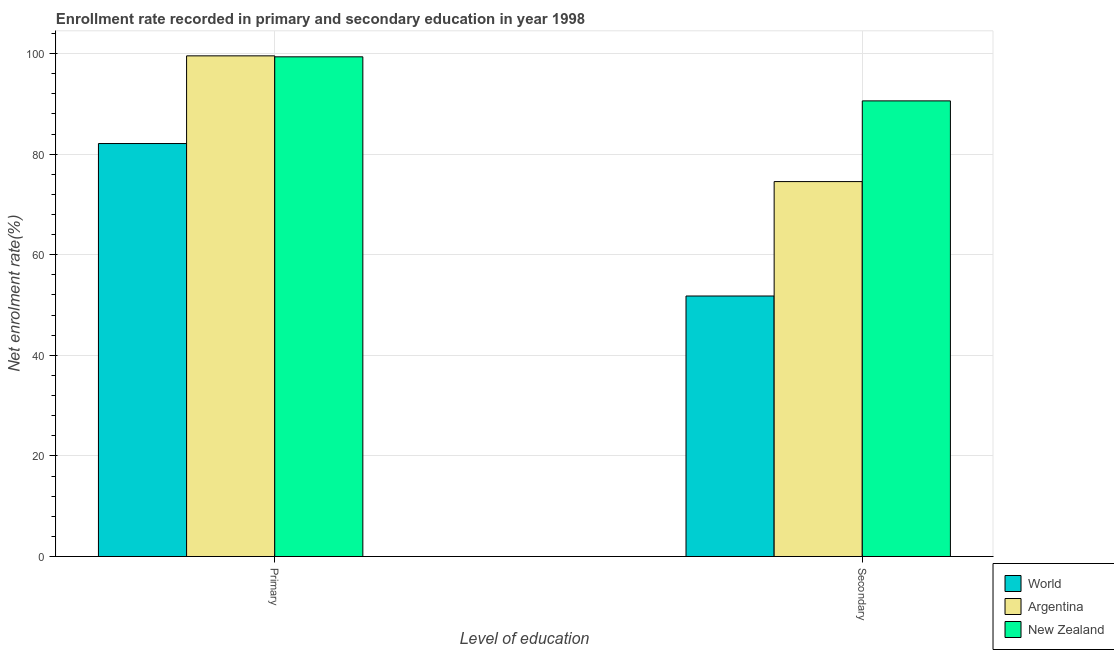How many groups of bars are there?
Make the answer very short. 2. How many bars are there on the 2nd tick from the left?
Your answer should be compact. 3. What is the label of the 1st group of bars from the left?
Offer a very short reply. Primary. What is the enrollment rate in secondary education in Argentina?
Your response must be concise. 74.55. Across all countries, what is the maximum enrollment rate in secondary education?
Keep it short and to the point. 90.59. Across all countries, what is the minimum enrollment rate in secondary education?
Keep it short and to the point. 51.8. In which country was the enrollment rate in primary education maximum?
Your answer should be very brief. Argentina. What is the total enrollment rate in primary education in the graph?
Keep it short and to the point. 281.01. What is the difference between the enrollment rate in secondary education in Argentina and that in New Zealand?
Provide a short and direct response. -16.04. What is the difference between the enrollment rate in primary education in World and the enrollment rate in secondary education in New Zealand?
Provide a short and direct response. -8.48. What is the average enrollment rate in primary education per country?
Your answer should be compact. 93.67. What is the difference between the enrollment rate in secondary education and enrollment rate in primary education in Argentina?
Give a very brief answer. -25. In how many countries, is the enrollment rate in primary education greater than 24 %?
Make the answer very short. 3. What is the ratio of the enrollment rate in primary education in World to that in Argentina?
Your answer should be compact. 0.82. Is the enrollment rate in secondary education in New Zealand less than that in Argentina?
Your answer should be very brief. No. What does the 3rd bar from the right in Secondary represents?
Make the answer very short. World. Are all the bars in the graph horizontal?
Provide a short and direct response. No. What is the difference between two consecutive major ticks on the Y-axis?
Provide a succinct answer. 20. Are the values on the major ticks of Y-axis written in scientific E-notation?
Ensure brevity in your answer.  No. Does the graph contain any zero values?
Provide a succinct answer. No. Where does the legend appear in the graph?
Give a very brief answer. Bottom right. How many legend labels are there?
Give a very brief answer. 3. What is the title of the graph?
Your answer should be very brief. Enrollment rate recorded in primary and secondary education in year 1998. Does "Europe(all income levels)" appear as one of the legend labels in the graph?
Give a very brief answer. No. What is the label or title of the X-axis?
Give a very brief answer. Level of education. What is the label or title of the Y-axis?
Offer a very short reply. Net enrolment rate(%). What is the Net enrolment rate(%) of World in Primary?
Your answer should be very brief. 82.11. What is the Net enrolment rate(%) in Argentina in Primary?
Keep it short and to the point. 99.55. What is the Net enrolment rate(%) in New Zealand in Primary?
Keep it short and to the point. 99.35. What is the Net enrolment rate(%) of World in Secondary?
Your answer should be compact. 51.8. What is the Net enrolment rate(%) in Argentina in Secondary?
Provide a succinct answer. 74.55. What is the Net enrolment rate(%) of New Zealand in Secondary?
Provide a short and direct response. 90.59. Across all Level of education, what is the maximum Net enrolment rate(%) in World?
Your answer should be very brief. 82.11. Across all Level of education, what is the maximum Net enrolment rate(%) in Argentina?
Your answer should be compact. 99.55. Across all Level of education, what is the maximum Net enrolment rate(%) in New Zealand?
Give a very brief answer. 99.35. Across all Level of education, what is the minimum Net enrolment rate(%) in World?
Your answer should be very brief. 51.8. Across all Level of education, what is the minimum Net enrolment rate(%) in Argentina?
Give a very brief answer. 74.55. Across all Level of education, what is the minimum Net enrolment rate(%) in New Zealand?
Provide a short and direct response. 90.59. What is the total Net enrolment rate(%) in World in the graph?
Offer a terse response. 133.91. What is the total Net enrolment rate(%) of Argentina in the graph?
Provide a succinct answer. 174.09. What is the total Net enrolment rate(%) in New Zealand in the graph?
Offer a very short reply. 189.94. What is the difference between the Net enrolment rate(%) of World in Primary and that in Secondary?
Ensure brevity in your answer.  30.32. What is the difference between the Net enrolment rate(%) in Argentina in Primary and that in Secondary?
Ensure brevity in your answer.  25. What is the difference between the Net enrolment rate(%) in New Zealand in Primary and that in Secondary?
Offer a terse response. 8.76. What is the difference between the Net enrolment rate(%) of World in Primary and the Net enrolment rate(%) of Argentina in Secondary?
Ensure brevity in your answer.  7.56. What is the difference between the Net enrolment rate(%) of World in Primary and the Net enrolment rate(%) of New Zealand in Secondary?
Offer a terse response. -8.48. What is the difference between the Net enrolment rate(%) of Argentina in Primary and the Net enrolment rate(%) of New Zealand in Secondary?
Your response must be concise. 8.95. What is the average Net enrolment rate(%) in World per Level of education?
Make the answer very short. 66.95. What is the average Net enrolment rate(%) in Argentina per Level of education?
Provide a short and direct response. 87.05. What is the average Net enrolment rate(%) in New Zealand per Level of education?
Offer a terse response. 94.97. What is the difference between the Net enrolment rate(%) in World and Net enrolment rate(%) in Argentina in Primary?
Offer a very short reply. -17.43. What is the difference between the Net enrolment rate(%) in World and Net enrolment rate(%) in New Zealand in Primary?
Your response must be concise. -17.24. What is the difference between the Net enrolment rate(%) of Argentina and Net enrolment rate(%) of New Zealand in Primary?
Provide a succinct answer. 0.19. What is the difference between the Net enrolment rate(%) in World and Net enrolment rate(%) in Argentina in Secondary?
Provide a succinct answer. -22.75. What is the difference between the Net enrolment rate(%) of World and Net enrolment rate(%) of New Zealand in Secondary?
Offer a very short reply. -38.8. What is the difference between the Net enrolment rate(%) of Argentina and Net enrolment rate(%) of New Zealand in Secondary?
Offer a very short reply. -16.04. What is the ratio of the Net enrolment rate(%) of World in Primary to that in Secondary?
Provide a succinct answer. 1.59. What is the ratio of the Net enrolment rate(%) of Argentina in Primary to that in Secondary?
Provide a succinct answer. 1.34. What is the ratio of the Net enrolment rate(%) of New Zealand in Primary to that in Secondary?
Your answer should be compact. 1.1. What is the difference between the highest and the second highest Net enrolment rate(%) of World?
Make the answer very short. 30.32. What is the difference between the highest and the second highest Net enrolment rate(%) in Argentina?
Keep it short and to the point. 25. What is the difference between the highest and the second highest Net enrolment rate(%) of New Zealand?
Your answer should be very brief. 8.76. What is the difference between the highest and the lowest Net enrolment rate(%) in World?
Keep it short and to the point. 30.32. What is the difference between the highest and the lowest Net enrolment rate(%) in Argentina?
Make the answer very short. 25. What is the difference between the highest and the lowest Net enrolment rate(%) in New Zealand?
Your answer should be compact. 8.76. 